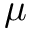Convert formula to latex. <formula><loc_0><loc_0><loc_500><loc_500>\mu</formula> 